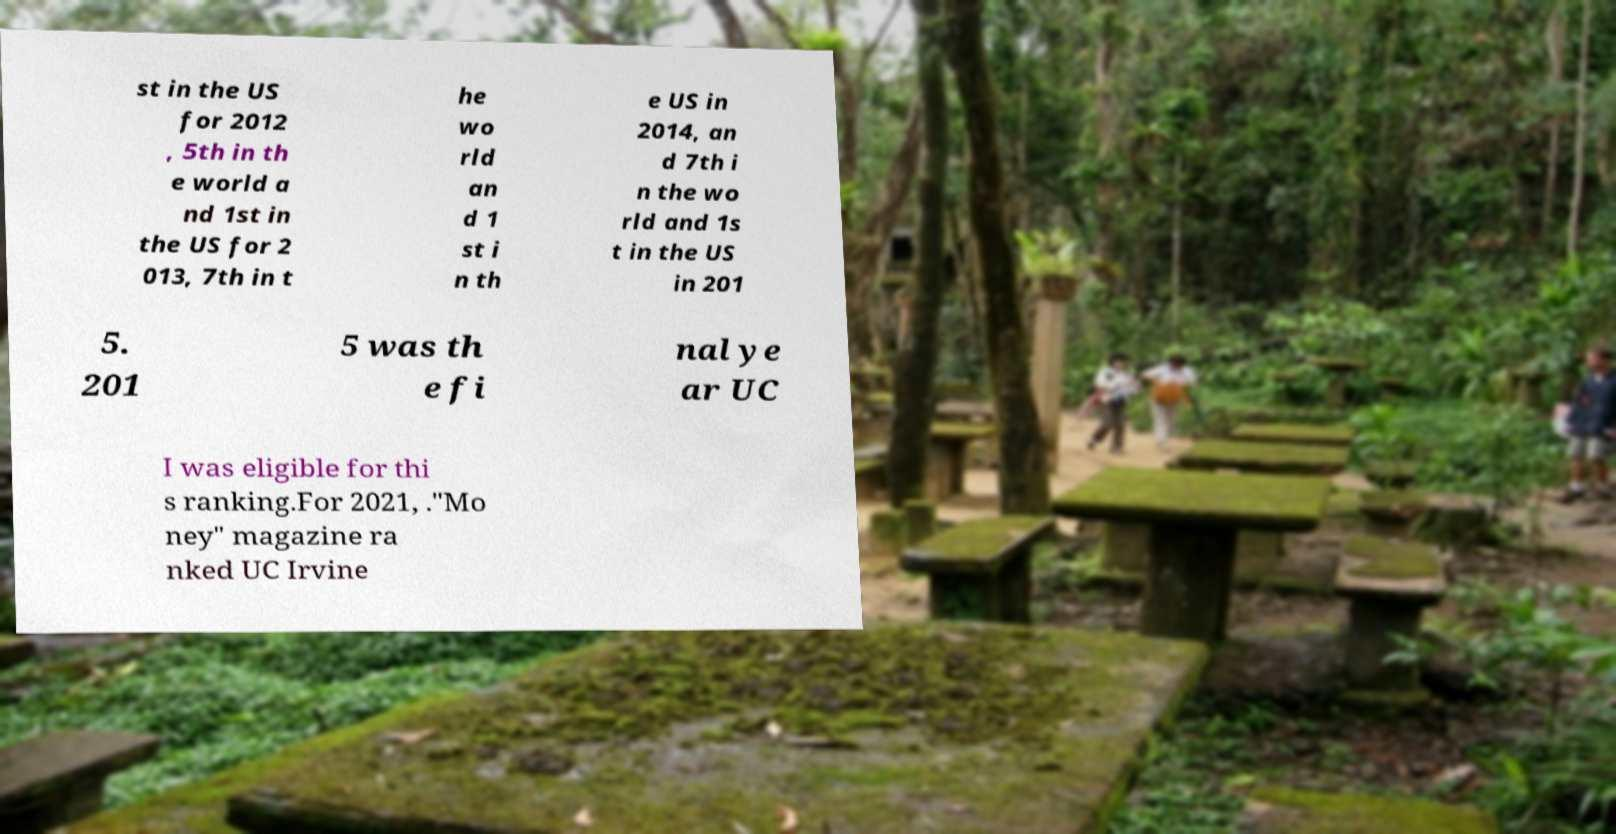What messages or text are displayed in this image? I need them in a readable, typed format. st in the US for 2012 , 5th in th e world a nd 1st in the US for 2 013, 7th in t he wo rld an d 1 st i n th e US in 2014, an d 7th i n the wo rld and 1s t in the US in 201 5. 201 5 was th e fi nal ye ar UC I was eligible for thi s ranking.For 2021, ."Mo ney" magazine ra nked UC Irvine 